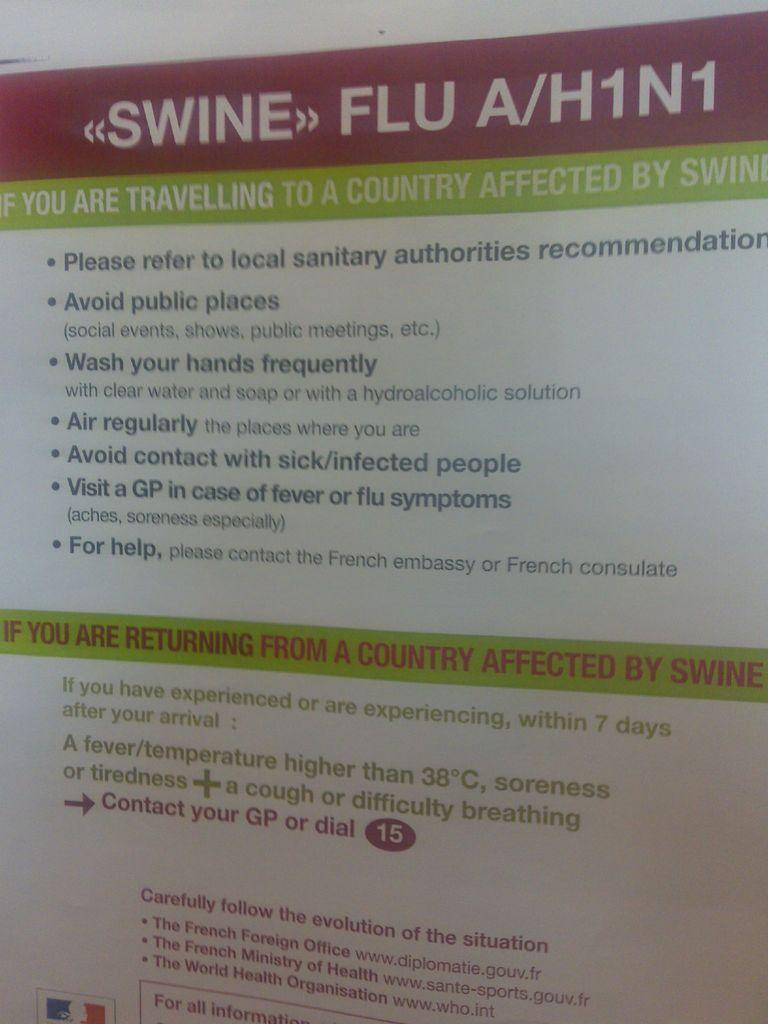<image>
Write a terse but informative summary of the picture. a poster that is titled 'swine flu a/h1n1 